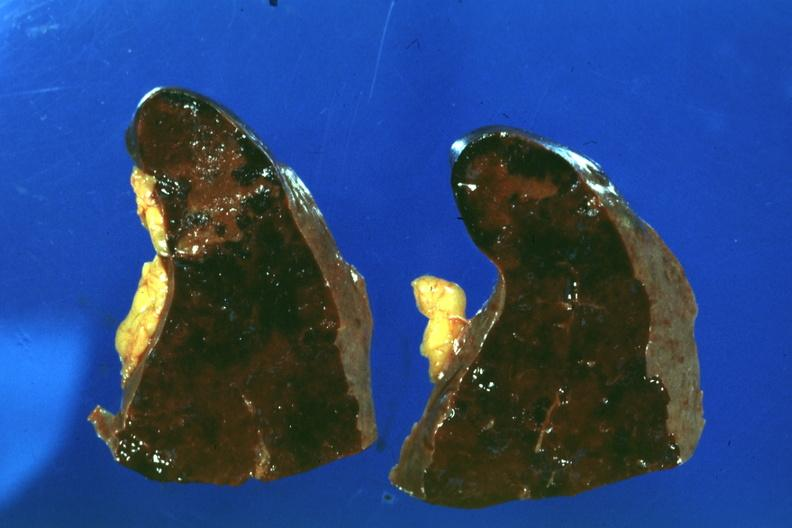what easily seen?
Answer the question using a single word or phrase. Congested spleen infarct 